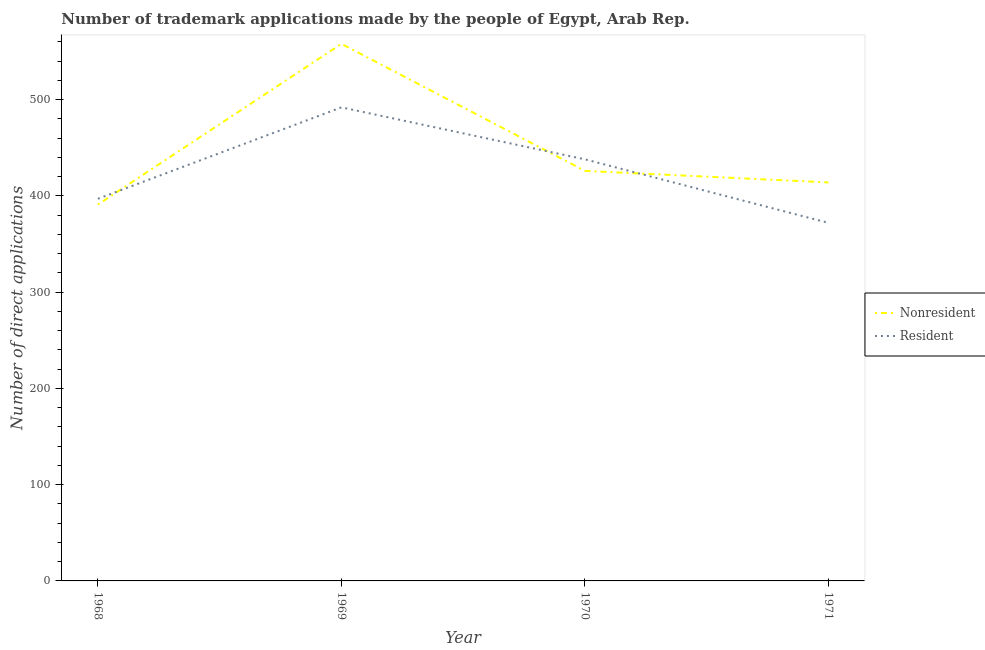What is the number of trademark applications made by non residents in 1969?
Your response must be concise. 558. Across all years, what is the maximum number of trademark applications made by residents?
Make the answer very short. 492. Across all years, what is the minimum number of trademark applications made by non residents?
Offer a very short reply. 391. In which year was the number of trademark applications made by residents maximum?
Make the answer very short. 1969. In which year was the number of trademark applications made by residents minimum?
Offer a terse response. 1971. What is the total number of trademark applications made by non residents in the graph?
Your answer should be very brief. 1789. What is the difference between the number of trademark applications made by residents in 1968 and that in 1971?
Your response must be concise. 25. What is the difference between the number of trademark applications made by non residents in 1971 and the number of trademark applications made by residents in 1969?
Provide a succinct answer. -78. What is the average number of trademark applications made by residents per year?
Ensure brevity in your answer.  424.75. In the year 1971, what is the difference between the number of trademark applications made by residents and number of trademark applications made by non residents?
Provide a succinct answer. -42. In how many years, is the number of trademark applications made by residents greater than 520?
Keep it short and to the point. 0. What is the ratio of the number of trademark applications made by non residents in 1968 to that in 1969?
Ensure brevity in your answer.  0.7. What is the difference between the highest and the second highest number of trademark applications made by residents?
Keep it short and to the point. 54. What is the difference between the highest and the lowest number of trademark applications made by residents?
Your answer should be very brief. 120. Is the number of trademark applications made by residents strictly less than the number of trademark applications made by non residents over the years?
Your answer should be compact. No. Does the graph contain grids?
Provide a succinct answer. No. Where does the legend appear in the graph?
Keep it short and to the point. Center right. How many legend labels are there?
Offer a terse response. 2. What is the title of the graph?
Give a very brief answer. Number of trademark applications made by the people of Egypt, Arab Rep. Does "Fixed telephone" appear as one of the legend labels in the graph?
Keep it short and to the point. No. What is the label or title of the Y-axis?
Make the answer very short. Number of direct applications. What is the Number of direct applications in Nonresident in 1968?
Offer a terse response. 391. What is the Number of direct applications of Resident in 1968?
Keep it short and to the point. 397. What is the Number of direct applications of Nonresident in 1969?
Offer a terse response. 558. What is the Number of direct applications of Resident in 1969?
Provide a succinct answer. 492. What is the Number of direct applications in Nonresident in 1970?
Keep it short and to the point. 426. What is the Number of direct applications of Resident in 1970?
Your response must be concise. 438. What is the Number of direct applications of Nonresident in 1971?
Your answer should be very brief. 414. What is the Number of direct applications in Resident in 1971?
Offer a terse response. 372. Across all years, what is the maximum Number of direct applications in Nonresident?
Offer a terse response. 558. Across all years, what is the maximum Number of direct applications of Resident?
Provide a succinct answer. 492. Across all years, what is the minimum Number of direct applications in Nonresident?
Make the answer very short. 391. Across all years, what is the minimum Number of direct applications of Resident?
Your answer should be compact. 372. What is the total Number of direct applications of Nonresident in the graph?
Give a very brief answer. 1789. What is the total Number of direct applications in Resident in the graph?
Your response must be concise. 1699. What is the difference between the Number of direct applications of Nonresident in 1968 and that in 1969?
Give a very brief answer. -167. What is the difference between the Number of direct applications in Resident in 1968 and that in 1969?
Provide a succinct answer. -95. What is the difference between the Number of direct applications of Nonresident in 1968 and that in 1970?
Your response must be concise. -35. What is the difference between the Number of direct applications of Resident in 1968 and that in 1970?
Ensure brevity in your answer.  -41. What is the difference between the Number of direct applications of Nonresident in 1968 and that in 1971?
Your answer should be compact. -23. What is the difference between the Number of direct applications of Nonresident in 1969 and that in 1970?
Keep it short and to the point. 132. What is the difference between the Number of direct applications of Resident in 1969 and that in 1970?
Your response must be concise. 54. What is the difference between the Number of direct applications of Nonresident in 1969 and that in 1971?
Make the answer very short. 144. What is the difference between the Number of direct applications of Resident in 1969 and that in 1971?
Provide a short and direct response. 120. What is the difference between the Number of direct applications in Nonresident in 1970 and that in 1971?
Offer a very short reply. 12. What is the difference between the Number of direct applications in Resident in 1970 and that in 1971?
Your answer should be compact. 66. What is the difference between the Number of direct applications in Nonresident in 1968 and the Number of direct applications in Resident in 1969?
Your answer should be compact. -101. What is the difference between the Number of direct applications in Nonresident in 1968 and the Number of direct applications in Resident in 1970?
Provide a short and direct response. -47. What is the difference between the Number of direct applications in Nonresident in 1968 and the Number of direct applications in Resident in 1971?
Offer a terse response. 19. What is the difference between the Number of direct applications of Nonresident in 1969 and the Number of direct applications of Resident in 1970?
Keep it short and to the point. 120. What is the difference between the Number of direct applications of Nonresident in 1969 and the Number of direct applications of Resident in 1971?
Make the answer very short. 186. What is the difference between the Number of direct applications in Nonresident in 1970 and the Number of direct applications in Resident in 1971?
Give a very brief answer. 54. What is the average Number of direct applications of Nonresident per year?
Your answer should be compact. 447.25. What is the average Number of direct applications of Resident per year?
Your response must be concise. 424.75. In the year 1969, what is the difference between the Number of direct applications of Nonresident and Number of direct applications of Resident?
Your response must be concise. 66. In the year 1970, what is the difference between the Number of direct applications of Nonresident and Number of direct applications of Resident?
Your response must be concise. -12. In the year 1971, what is the difference between the Number of direct applications in Nonresident and Number of direct applications in Resident?
Your response must be concise. 42. What is the ratio of the Number of direct applications of Nonresident in 1968 to that in 1969?
Ensure brevity in your answer.  0.7. What is the ratio of the Number of direct applications of Resident in 1968 to that in 1969?
Offer a very short reply. 0.81. What is the ratio of the Number of direct applications of Nonresident in 1968 to that in 1970?
Make the answer very short. 0.92. What is the ratio of the Number of direct applications of Resident in 1968 to that in 1970?
Offer a very short reply. 0.91. What is the ratio of the Number of direct applications in Nonresident in 1968 to that in 1971?
Your response must be concise. 0.94. What is the ratio of the Number of direct applications of Resident in 1968 to that in 1971?
Provide a succinct answer. 1.07. What is the ratio of the Number of direct applications of Nonresident in 1969 to that in 1970?
Keep it short and to the point. 1.31. What is the ratio of the Number of direct applications of Resident in 1969 to that in 1970?
Your response must be concise. 1.12. What is the ratio of the Number of direct applications of Nonresident in 1969 to that in 1971?
Give a very brief answer. 1.35. What is the ratio of the Number of direct applications in Resident in 1969 to that in 1971?
Ensure brevity in your answer.  1.32. What is the ratio of the Number of direct applications in Resident in 1970 to that in 1971?
Provide a succinct answer. 1.18. What is the difference between the highest and the second highest Number of direct applications of Nonresident?
Your answer should be very brief. 132. What is the difference between the highest and the second highest Number of direct applications in Resident?
Make the answer very short. 54. What is the difference between the highest and the lowest Number of direct applications in Nonresident?
Your answer should be compact. 167. What is the difference between the highest and the lowest Number of direct applications of Resident?
Give a very brief answer. 120. 